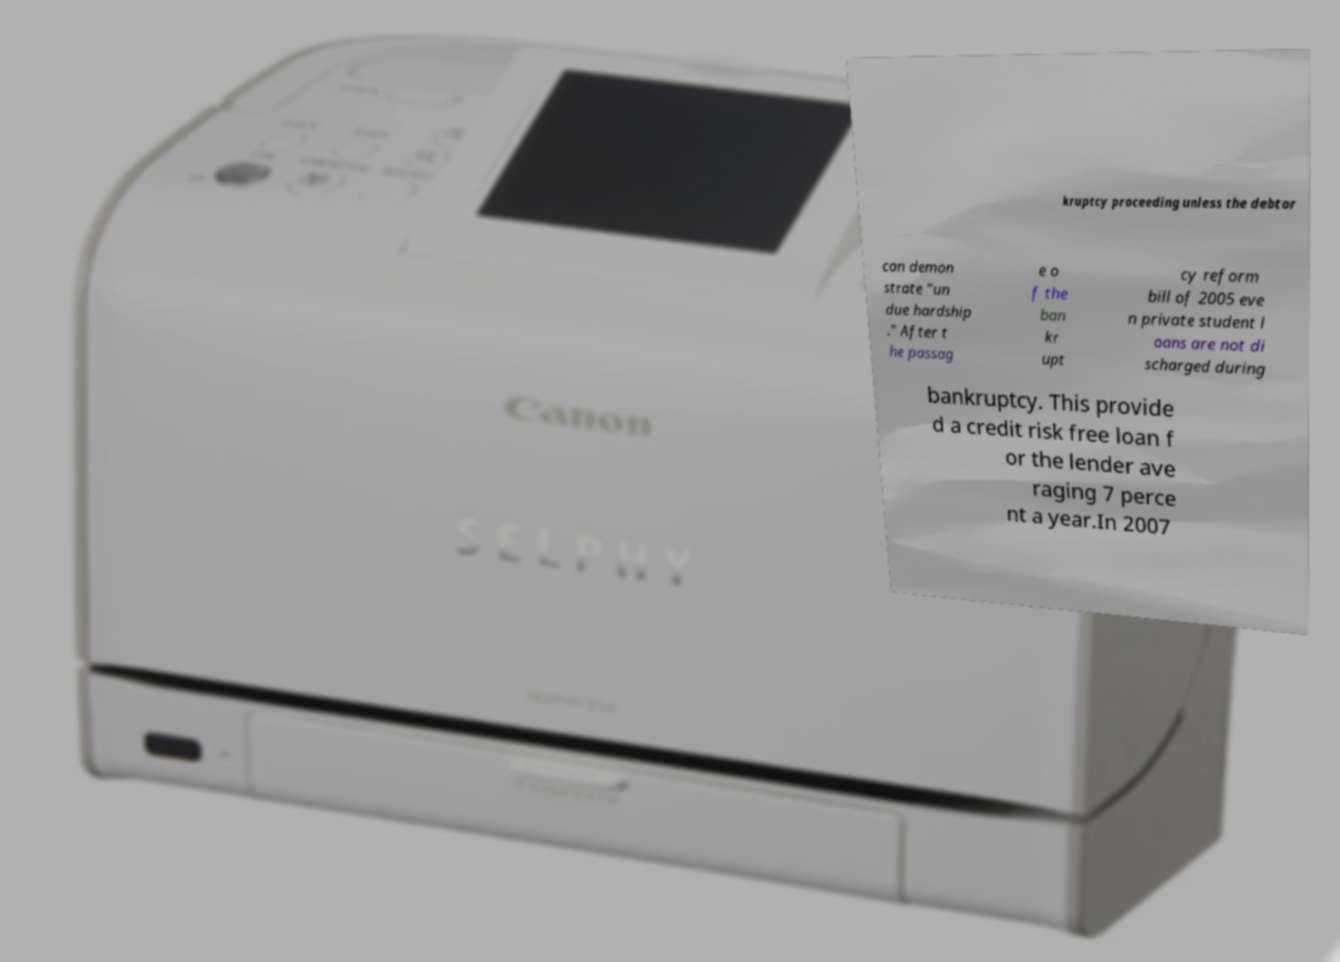Can you read and provide the text displayed in the image?This photo seems to have some interesting text. Can you extract and type it out for me? kruptcy proceeding unless the debtor can demon strate "un due hardship ." After t he passag e o f the ban kr upt cy reform bill of 2005 eve n private student l oans are not di scharged during bankruptcy. This provide d a credit risk free loan f or the lender ave raging 7 perce nt a year.In 2007 